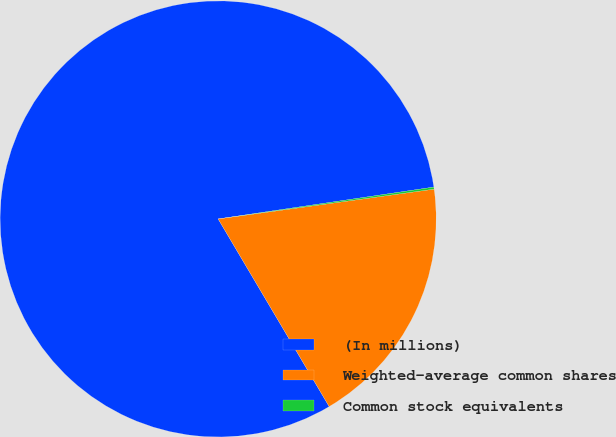<chart> <loc_0><loc_0><loc_500><loc_500><pie_chart><fcel>(In millions)<fcel>Weighted-average common shares<fcel>Common stock equivalents<nl><fcel>81.17%<fcel>18.68%<fcel>0.15%<nl></chart> 